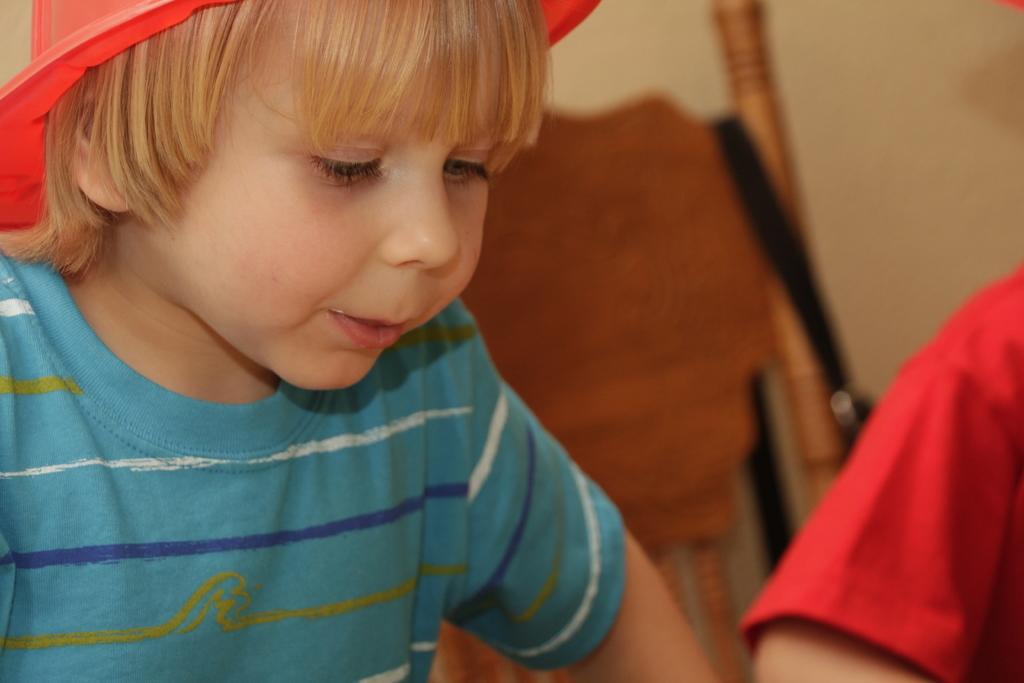In one or two sentences, can you explain what this image depicts? In the picture I can see a boy is wearing a t-shirt and a hat. In the background I can see some objects and a person's hand. The background of the image is blurred. 